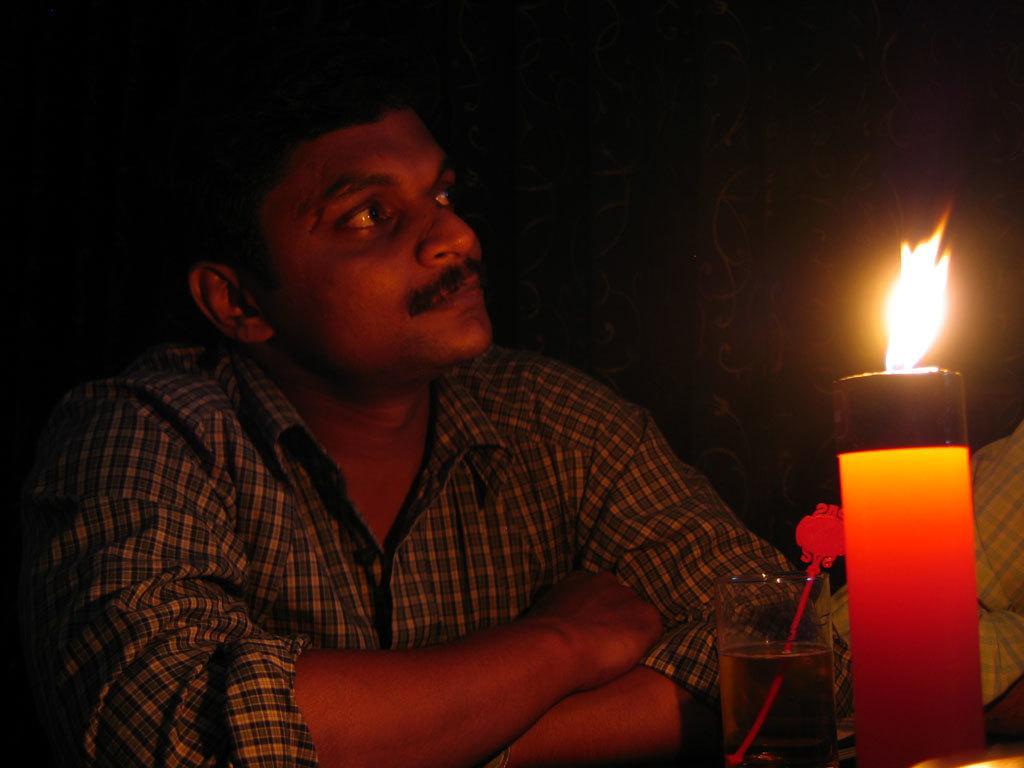In one or two sentences, can you explain what this image depicts? Here we can see a man sitting and there is a glass with wine and a stick in it and a candle light on a platform. On the right we can see a person hand. In the background we can see a curtain. 